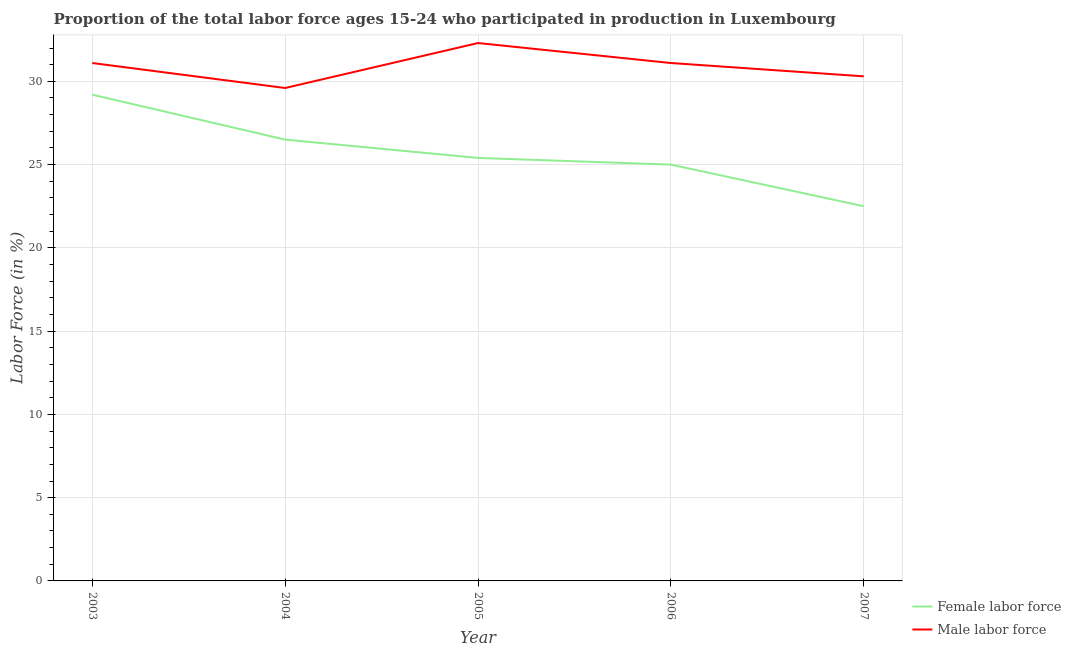How many different coloured lines are there?
Provide a succinct answer. 2. What is the percentage of female labor force in 2005?
Your answer should be very brief. 25.4. Across all years, what is the maximum percentage of female labor force?
Make the answer very short. 29.2. Across all years, what is the minimum percentage of male labour force?
Ensure brevity in your answer.  29.6. In which year was the percentage of male labour force maximum?
Provide a short and direct response. 2005. What is the total percentage of male labour force in the graph?
Offer a terse response. 154.4. What is the difference between the percentage of female labor force in 2005 and that in 2006?
Your answer should be very brief. 0.4. What is the difference between the percentage of male labour force in 2004 and the percentage of female labor force in 2003?
Ensure brevity in your answer.  0.4. What is the average percentage of male labour force per year?
Your response must be concise. 30.88. In the year 2007, what is the difference between the percentage of female labor force and percentage of male labour force?
Your answer should be very brief. -7.8. What is the ratio of the percentage of female labor force in 2005 to that in 2007?
Your response must be concise. 1.13. Is the difference between the percentage of male labour force in 2006 and 2007 greater than the difference between the percentage of female labor force in 2006 and 2007?
Provide a succinct answer. No. What is the difference between the highest and the second highest percentage of female labor force?
Offer a terse response. 2.7. What is the difference between the highest and the lowest percentage of female labor force?
Ensure brevity in your answer.  6.7. Is the sum of the percentage of male labour force in 2004 and 2006 greater than the maximum percentage of female labor force across all years?
Provide a succinct answer. Yes. Does the percentage of male labour force monotonically increase over the years?
Make the answer very short. No. How many years are there in the graph?
Keep it short and to the point. 5. What is the difference between two consecutive major ticks on the Y-axis?
Offer a very short reply. 5. Does the graph contain any zero values?
Offer a very short reply. No. Does the graph contain grids?
Your response must be concise. Yes. Where does the legend appear in the graph?
Offer a terse response. Bottom right. How many legend labels are there?
Your answer should be compact. 2. How are the legend labels stacked?
Your answer should be compact. Vertical. What is the title of the graph?
Your answer should be very brief. Proportion of the total labor force ages 15-24 who participated in production in Luxembourg. Does "Working capital" appear as one of the legend labels in the graph?
Offer a very short reply. No. What is the label or title of the Y-axis?
Offer a very short reply. Labor Force (in %). What is the Labor Force (in %) in Female labor force in 2003?
Make the answer very short. 29.2. What is the Labor Force (in %) in Male labor force in 2003?
Your answer should be very brief. 31.1. What is the Labor Force (in %) in Female labor force in 2004?
Give a very brief answer. 26.5. What is the Labor Force (in %) in Male labor force in 2004?
Keep it short and to the point. 29.6. What is the Labor Force (in %) of Female labor force in 2005?
Provide a succinct answer. 25.4. What is the Labor Force (in %) in Male labor force in 2005?
Keep it short and to the point. 32.3. What is the Labor Force (in %) of Female labor force in 2006?
Ensure brevity in your answer.  25. What is the Labor Force (in %) in Male labor force in 2006?
Provide a short and direct response. 31.1. What is the Labor Force (in %) of Female labor force in 2007?
Give a very brief answer. 22.5. What is the Labor Force (in %) of Male labor force in 2007?
Your answer should be compact. 30.3. Across all years, what is the maximum Labor Force (in %) of Female labor force?
Keep it short and to the point. 29.2. Across all years, what is the maximum Labor Force (in %) in Male labor force?
Make the answer very short. 32.3. Across all years, what is the minimum Labor Force (in %) of Female labor force?
Your response must be concise. 22.5. Across all years, what is the minimum Labor Force (in %) of Male labor force?
Make the answer very short. 29.6. What is the total Labor Force (in %) of Female labor force in the graph?
Your answer should be very brief. 128.6. What is the total Labor Force (in %) in Male labor force in the graph?
Offer a very short reply. 154.4. What is the difference between the Labor Force (in %) in Female labor force in 2003 and that in 2004?
Keep it short and to the point. 2.7. What is the difference between the Labor Force (in %) of Male labor force in 2003 and that in 2004?
Offer a very short reply. 1.5. What is the difference between the Labor Force (in %) of Male labor force in 2003 and that in 2005?
Make the answer very short. -1.2. What is the difference between the Labor Force (in %) in Female labor force in 2003 and that in 2006?
Keep it short and to the point. 4.2. What is the difference between the Labor Force (in %) in Male labor force in 2003 and that in 2007?
Your answer should be very brief. 0.8. What is the difference between the Labor Force (in %) of Female labor force in 2004 and that in 2005?
Offer a very short reply. 1.1. What is the difference between the Labor Force (in %) of Male labor force in 2004 and that in 2005?
Keep it short and to the point. -2.7. What is the difference between the Labor Force (in %) of Male labor force in 2004 and that in 2006?
Give a very brief answer. -1.5. What is the difference between the Labor Force (in %) of Female labor force in 2005 and that in 2007?
Offer a very short reply. 2.9. What is the difference between the Labor Force (in %) in Female labor force in 2006 and that in 2007?
Ensure brevity in your answer.  2.5. What is the difference between the Labor Force (in %) of Male labor force in 2006 and that in 2007?
Provide a succinct answer. 0.8. What is the difference between the Labor Force (in %) in Female labor force in 2003 and the Labor Force (in %) in Male labor force in 2004?
Offer a very short reply. -0.4. What is the difference between the Labor Force (in %) of Female labor force in 2003 and the Labor Force (in %) of Male labor force in 2007?
Provide a succinct answer. -1.1. What is the difference between the Labor Force (in %) in Female labor force in 2004 and the Labor Force (in %) in Male labor force in 2005?
Make the answer very short. -5.8. What is the difference between the Labor Force (in %) of Female labor force in 2004 and the Labor Force (in %) of Male labor force in 2007?
Provide a succinct answer. -3.8. What is the difference between the Labor Force (in %) of Female labor force in 2005 and the Labor Force (in %) of Male labor force in 2007?
Offer a terse response. -4.9. What is the average Labor Force (in %) of Female labor force per year?
Offer a very short reply. 25.72. What is the average Labor Force (in %) of Male labor force per year?
Your answer should be very brief. 30.88. In the year 2004, what is the difference between the Labor Force (in %) of Female labor force and Labor Force (in %) of Male labor force?
Provide a short and direct response. -3.1. In the year 2005, what is the difference between the Labor Force (in %) in Female labor force and Labor Force (in %) in Male labor force?
Offer a terse response. -6.9. In the year 2006, what is the difference between the Labor Force (in %) in Female labor force and Labor Force (in %) in Male labor force?
Provide a succinct answer. -6.1. What is the ratio of the Labor Force (in %) of Female labor force in 2003 to that in 2004?
Ensure brevity in your answer.  1.1. What is the ratio of the Labor Force (in %) in Male labor force in 2003 to that in 2004?
Your answer should be very brief. 1.05. What is the ratio of the Labor Force (in %) in Female labor force in 2003 to that in 2005?
Your answer should be compact. 1.15. What is the ratio of the Labor Force (in %) of Male labor force in 2003 to that in 2005?
Make the answer very short. 0.96. What is the ratio of the Labor Force (in %) in Female labor force in 2003 to that in 2006?
Your answer should be very brief. 1.17. What is the ratio of the Labor Force (in %) in Male labor force in 2003 to that in 2006?
Provide a short and direct response. 1. What is the ratio of the Labor Force (in %) in Female labor force in 2003 to that in 2007?
Keep it short and to the point. 1.3. What is the ratio of the Labor Force (in %) of Male labor force in 2003 to that in 2007?
Your answer should be very brief. 1.03. What is the ratio of the Labor Force (in %) of Female labor force in 2004 to that in 2005?
Your response must be concise. 1.04. What is the ratio of the Labor Force (in %) of Male labor force in 2004 to that in 2005?
Ensure brevity in your answer.  0.92. What is the ratio of the Labor Force (in %) in Female labor force in 2004 to that in 2006?
Offer a very short reply. 1.06. What is the ratio of the Labor Force (in %) of Male labor force in 2004 to that in 2006?
Your answer should be compact. 0.95. What is the ratio of the Labor Force (in %) of Female labor force in 2004 to that in 2007?
Make the answer very short. 1.18. What is the ratio of the Labor Force (in %) in Male labor force in 2004 to that in 2007?
Offer a very short reply. 0.98. What is the ratio of the Labor Force (in %) in Female labor force in 2005 to that in 2006?
Your answer should be very brief. 1.02. What is the ratio of the Labor Force (in %) in Male labor force in 2005 to that in 2006?
Provide a short and direct response. 1.04. What is the ratio of the Labor Force (in %) in Female labor force in 2005 to that in 2007?
Offer a very short reply. 1.13. What is the ratio of the Labor Force (in %) in Male labor force in 2005 to that in 2007?
Provide a succinct answer. 1.07. What is the ratio of the Labor Force (in %) of Male labor force in 2006 to that in 2007?
Give a very brief answer. 1.03. What is the difference between the highest and the second highest Labor Force (in %) of Male labor force?
Provide a short and direct response. 1.2. What is the difference between the highest and the lowest Labor Force (in %) of Female labor force?
Offer a very short reply. 6.7. What is the difference between the highest and the lowest Labor Force (in %) in Male labor force?
Offer a terse response. 2.7. 